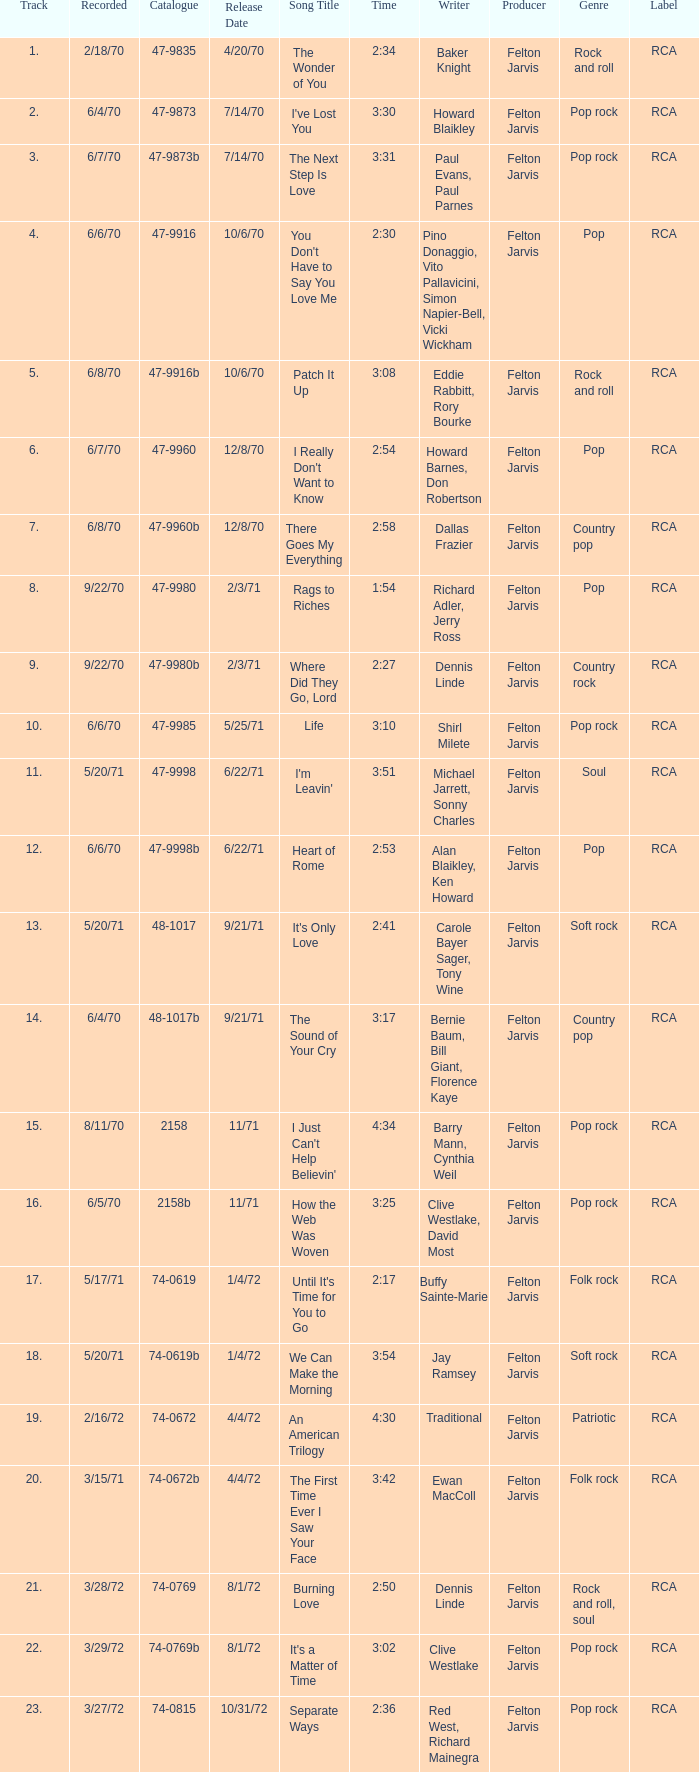What is the catalogue number for the song that is 3:17 and was released 9/21/71? 48-1017b. 